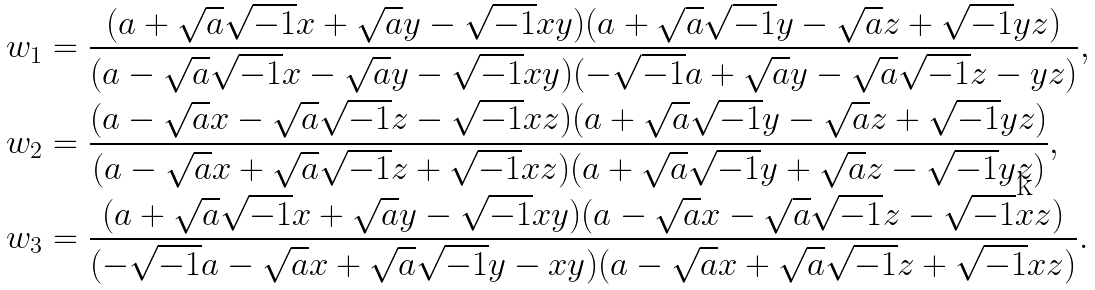Convert formula to latex. <formula><loc_0><loc_0><loc_500><loc_500>w _ { 1 } & = \frac { ( a + \sqrt { a } \sqrt { - 1 } x + \sqrt { a } y - \sqrt { - 1 } x y ) ( a + \sqrt { a } \sqrt { - 1 } y - \sqrt { a } z + \sqrt { - 1 } y z ) } { ( a - \sqrt { a } \sqrt { - 1 } x - \sqrt { a } y - \sqrt { - 1 } x y ) ( - \sqrt { - 1 } a + \sqrt { a } y - \sqrt { a } \sqrt { - 1 } z - y z ) } , \\ w _ { 2 } & = \frac { ( a - \sqrt { a } x - \sqrt { a } \sqrt { - 1 } z - \sqrt { - 1 } x z ) ( a + \sqrt { a } \sqrt { - 1 } y - \sqrt { a } z + \sqrt { - 1 } y z ) } { ( a - \sqrt { a } x + \sqrt { a } \sqrt { - 1 } z + \sqrt { - 1 } x z ) ( a + \sqrt { a } \sqrt { - 1 } y + \sqrt { a } z - \sqrt { - 1 } y z ) } , \\ w _ { 3 } & = \frac { ( a + \sqrt { a } \sqrt { - 1 } x + \sqrt { a } y - \sqrt { - 1 } x y ) ( a - \sqrt { a } x - \sqrt { a } \sqrt { - 1 } z - \sqrt { - 1 } x z ) } { ( - \sqrt { - 1 } a - \sqrt { a } x + \sqrt { a } \sqrt { - 1 } y - x y ) ( a - \sqrt { a } x + \sqrt { a } \sqrt { - 1 } z + \sqrt { - 1 } x z ) } .</formula> 